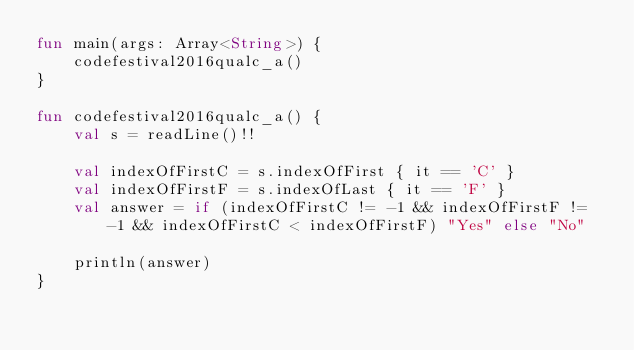Convert code to text. <code><loc_0><loc_0><loc_500><loc_500><_Kotlin_>fun main(args: Array<String>) {
    codefestival2016qualc_a()
}

fun codefestival2016qualc_a() {
    val s = readLine()!!

    val indexOfFirstC = s.indexOfFirst { it == 'C' }
    val indexOfFirstF = s.indexOfLast { it == 'F' }
    val answer = if (indexOfFirstC != -1 && indexOfFirstF != -1 && indexOfFirstC < indexOfFirstF) "Yes" else "No"

    println(answer)
}
</code> 